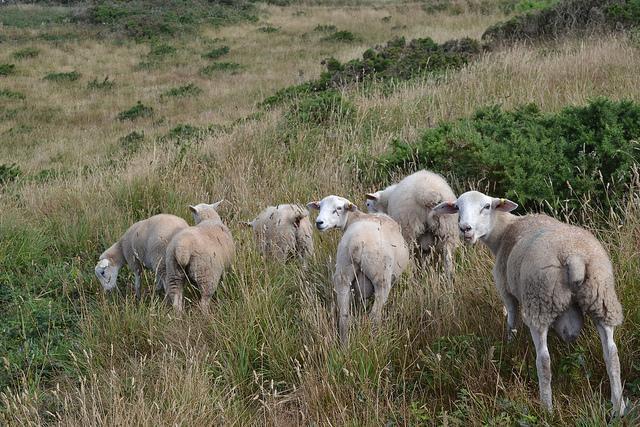How many sheep are there?
Give a very brief answer. 6. How many animals are there?
Give a very brief answer. 6. How many sheep are facing the camera?
Give a very brief answer. 2. 